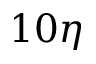Convert formula to latex. <formula><loc_0><loc_0><loc_500><loc_500>1 0 \eta</formula> 